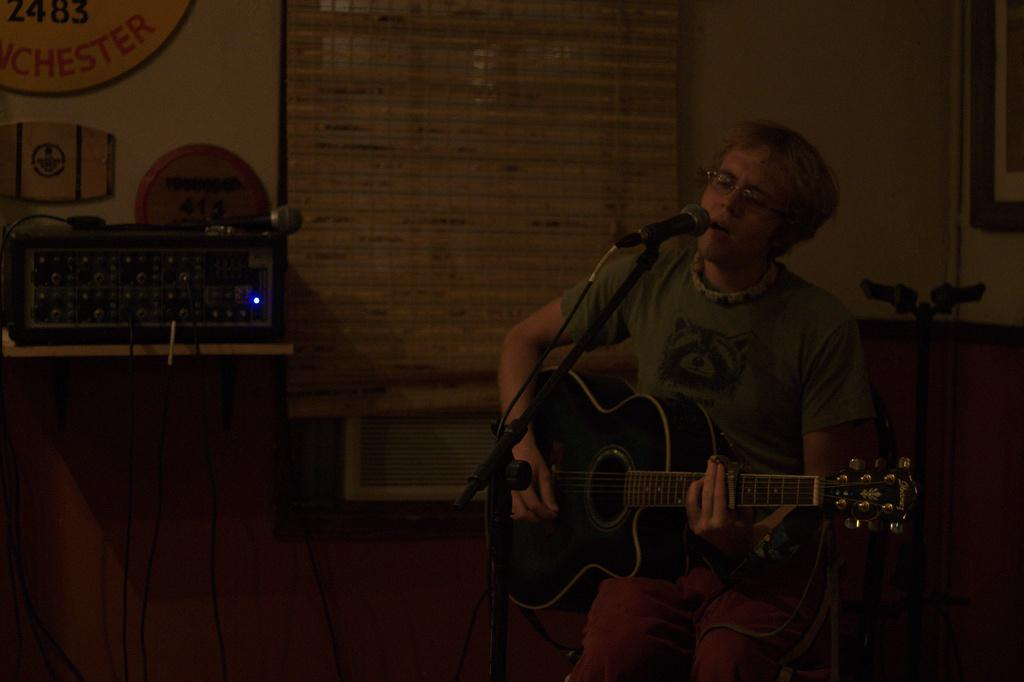What is the man in the image holding? The man is holding a guitar. What is the man doing with the microphone in front of him? The man has a microphone in front of him, which suggests he might be singing or speaking. What can be seen in the background of the image? There is an amplifier in the background of the image. What is the purpose of the microphone on the amplifier? The microphone on the amplifier is likely used to amplify the sound from the microphone in front of the man. What is the appearance of the curtain beside the man? There is a curtain beside the man, but no specific details about its appearance are provided. How many babies are visible in the image? There are no babies present in the image. What type of pie is being served on the amplifier? There is no pie present in the image. 